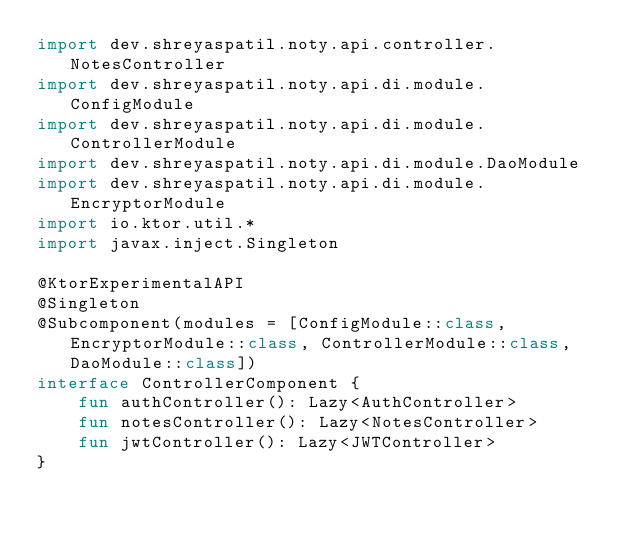Convert code to text. <code><loc_0><loc_0><loc_500><loc_500><_Kotlin_>import dev.shreyaspatil.noty.api.controller.NotesController
import dev.shreyaspatil.noty.api.di.module.ConfigModule
import dev.shreyaspatil.noty.api.di.module.ControllerModule
import dev.shreyaspatil.noty.api.di.module.DaoModule
import dev.shreyaspatil.noty.api.di.module.EncryptorModule
import io.ktor.util.*
import javax.inject.Singleton

@KtorExperimentalAPI
@Singleton
@Subcomponent(modules = [ConfigModule::class, EncryptorModule::class, ControllerModule::class, DaoModule::class])
interface ControllerComponent {
    fun authController(): Lazy<AuthController>
    fun notesController(): Lazy<NotesController>
    fun jwtController(): Lazy<JWTController>
}</code> 